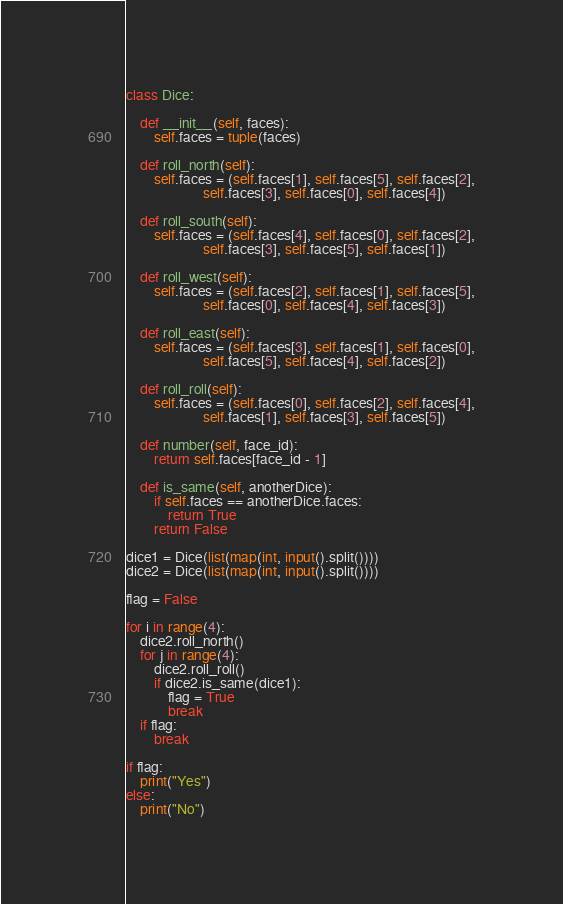Convert code to text. <code><loc_0><loc_0><loc_500><loc_500><_Python_>class Dice:
 
    def __init__(self, faces):
        self.faces = tuple(faces)
 
    def roll_north(self):
        self.faces = (self.faces[1], self.faces[5], self.faces[2],
                      self.faces[3], self.faces[0], self.faces[4])
 
    def roll_south(self):
        self.faces = (self.faces[4], self.faces[0], self.faces[2],
                      self.faces[3], self.faces[5], self.faces[1])
 
    def roll_west(self):
        self.faces = (self.faces[2], self.faces[1], self.faces[5],
                      self.faces[0], self.faces[4], self.faces[3])
 
    def roll_east(self):
        self.faces = (self.faces[3], self.faces[1], self.faces[0],
                      self.faces[5], self.faces[4], self.faces[2])
    
    def roll_roll(self):
        self.faces = (self.faces[0], self.faces[2], self.faces[4],
                      self.faces[1], self.faces[3], self.faces[5])
 
    def number(self, face_id):
        return self.faces[face_id - 1]

    def is_same(self, anotherDice):
        if self.faces == anotherDice.faces:
            return True
        return False
 
dice1 = Dice(list(map(int, input().split())))
dice2 = Dice(list(map(int, input().split())))

flag = False

for i in range(4):
    dice2.roll_north()
    for j in range(4):
        dice2.roll_roll()
        if dice2.is_same(dice1):
            flag = True
            break
    if flag:
        break

if flag:
    print("Yes")
else:
    print("No")</code> 